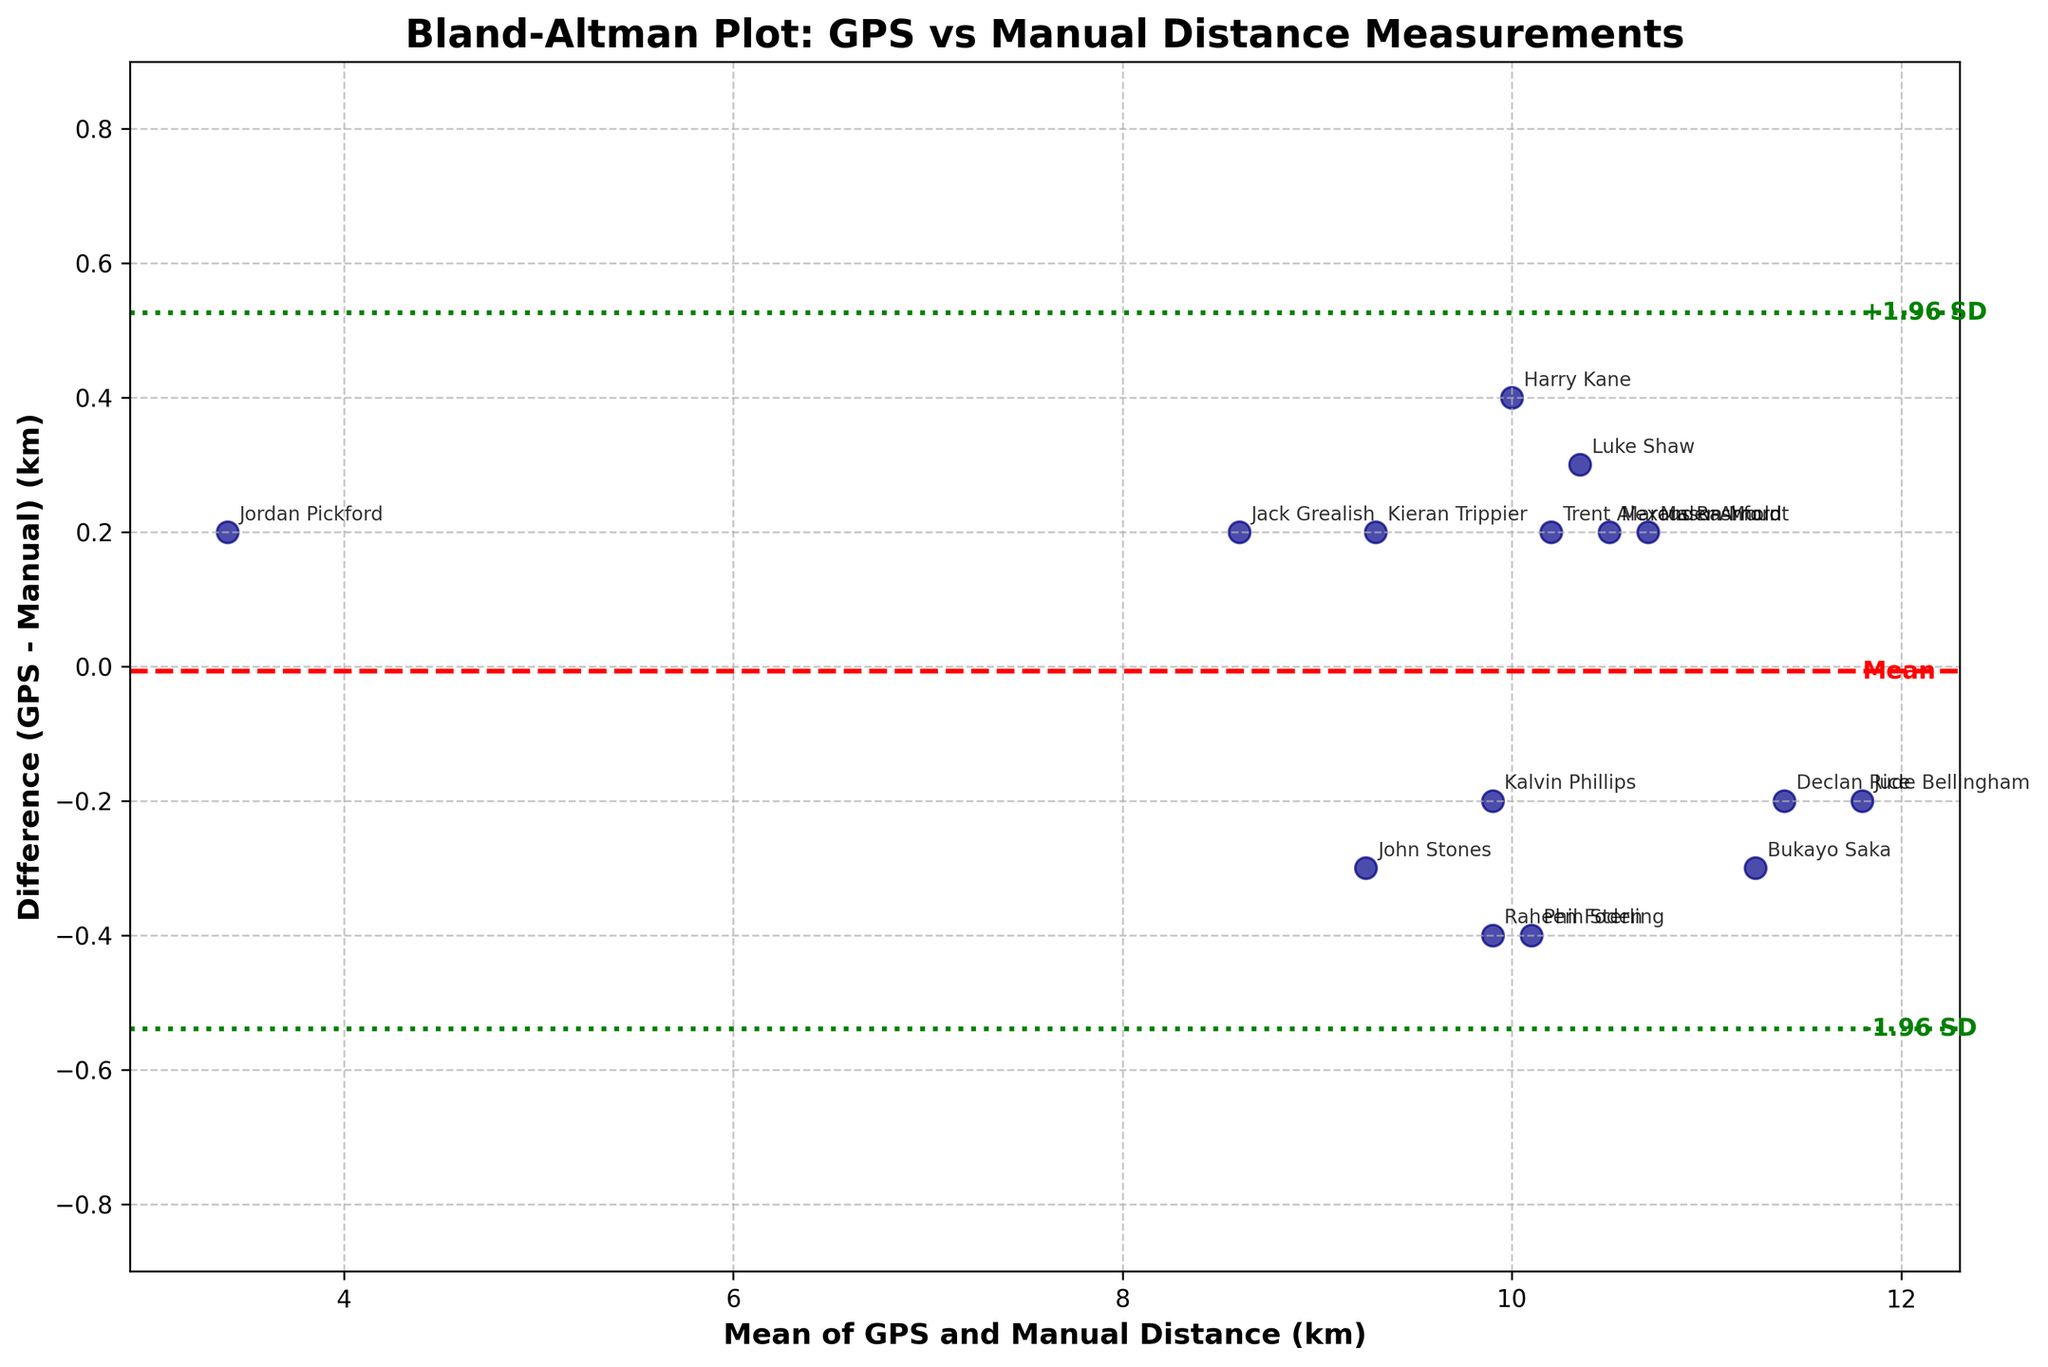What is the title of the plot? The title of the plot is displayed prominently at the top of the figure and provides context about the data being represented.
Answer: Bland-Altman Plot: GPS vs Manual Distance Measurements What do the x and y-axis represent? The x-axis label indicates it represents the mean of GPS and Manual Distance (km), while the y-axis label shows it represents the difference (GPS - Manual) (km).
Answer: x-axis: Mean of GPS and Manual Distance (km), y-axis: Difference (GPS - Manual) (km) How many data points are there in the plot? To determine the number of data points, one can count each scatter point shown in the plot. There are 15 players listed in the data, which corresponds to 15 points on the plot.
Answer: 15 Which player had the highest difference (GPS - Manual) and what was the value? The plot shows individual player names next to their data points. The player with the highest difference will be the point furthest along the positive y-axis.
Answer: Jude Bellingham, 0.2 km What are the values of the limits of agreement (LOA) lines? The limits of agreement lines are indicated by the upper and lower green dashed lines. The upper LOA is marked '+1.96 SD' and the lower LOA is marked '-1.96 SD'.
Answer: Upper LOA: 0.28 km, Lower LOA: -0.3 km What is the mean difference between GPS and manual distance measurements? The mean difference is shown by the red dashed line, labeled 'Mean', which aligns with the horizontal line at this value.
Answer: 0 km Which player is closest to the mean line (red dashed line)? To find the player closest to the red dashed mean line, look for the data point that is nearest horizontally to this line at 0 km on the y-axis.
Answer: Kalvin Phillips Which player shows the largest negative difference (GPS - Manual)? The player with the largest negative difference would be farthest down the y-axis; annotation indicates their name.
Answer: John Stones What is the approximate mean distance for Jordan Pickford? Jordan Pickford's data point can be identified, and his mean value is found on the x-axis directly below his data point.
Answer: Approximately 3.4 km Is there a trend or bias apparent between the GPS and manual measurements based on this Bland-Altman plot? By observing how data points are distributed above and below the mean difference line, one can assess if there is consistent deviation, indicating systematic bias. Points appear somewhat evenly distributed, suggesting little systematic bias.
Answer: No clear trend or significant bias 